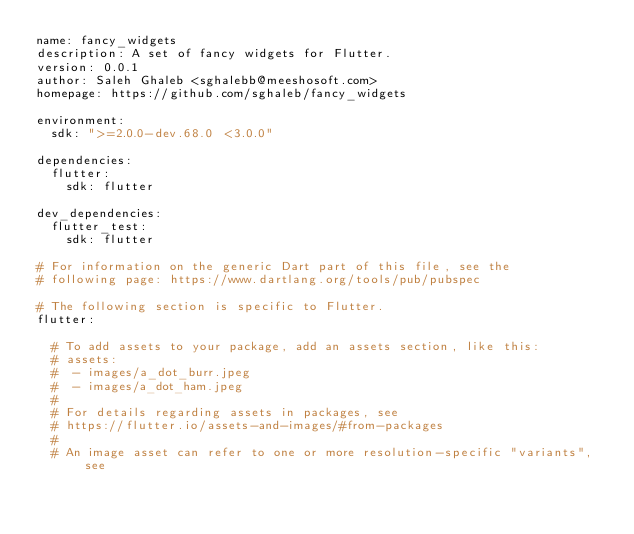<code> <loc_0><loc_0><loc_500><loc_500><_YAML_>name: fancy_widgets
description: A set of fancy widgets for Flutter.
version: 0.0.1
author: Saleh Ghaleb <sghalebb@meeshosoft.com>
homepage: https://github.com/sghaleb/fancy_widgets

environment:
  sdk: ">=2.0.0-dev.68.0 <3.0.0"

dependencies:
  flutter:
    sdk: flutter

dev_dependencies:
  flutter_test:
    sdk: flutter

# For information on the generic Dart part of this file, see the
# following page: https://www.dartlang.org/tools/pub/pubspec

# The following section is specific to Flutter.
flutter:

  # To add assets to your package, add an assets section, like this:
  # assets:
  #  - images/a_dot_burr.jpeg
  #  - images/a_dot_ham.jpeg
  #
  # For details regarding assets in packages, see
  # https://flutter.io/assets-and-images/#from-packages
  #
  # An image asset can refer to one or more resolution-specific "variants", see</code> 